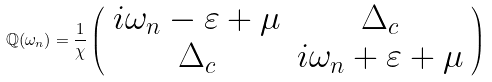<formula> <loc_0><loc_0><loc_500><loc_500>\mathbb { Q } ( \omega _ { n } ) = \frac { 1 } { \chi } \left ( \begin{array} { c c } i \omega _ { n } - \varepsilon + \mu & \Delta _ { c } \\ \Delta _ { c } & i \omega _ { n } + \varepsilon + \mu \end{array} \right )</formula> 